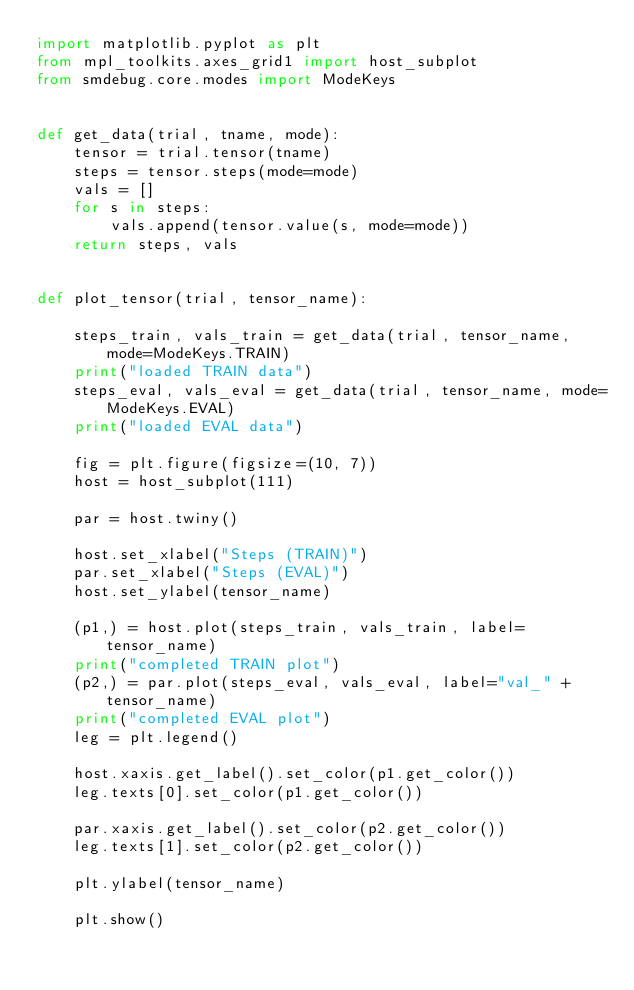Convert code to text. <code><loc_0><loc_0><loc_500><loc_500><_Python_>import matplotlib.pyplot as plt
from mpl_toolkits.axes_grid1 import host_subplot
from smdebug.core.modes import ModeKeys


def get_data(trial, tname, mode):
    tensor = trial.tensor(tname)
    steps = tensor.steps(mode=mode)
    vals = []
    for s in steps:
        vals.append(tensor.value(s, mode=mode))
    return steps, vals


def plot_tensor(trial, tensor_name):

    steps_train, vals_train = get_data(trial, tensor_name, mode=ModeKeys.TRAIN)
    print("loaded TRAIN data")
    steps_eval, vals_eval = get_data(trial, tensor_name, mode=ModeKeys.EVAL)
    print("loaded EVAL data")

    fig = plt.figure(figsize=(10, 7))
    host = host_subplot(111)

    par = host.twiny()

    host.set_xlabel("Steps (TRAIN)")
    par.set_xlabel("Steps (EVAL)")
    host.set_ylabel(tensor_name)

    (p1,) = host.plot(steps_train, vals_train, label=tensor_name)
    print("completed TRAIN plot")
    (p2,) = par.plot(steps_eval, vals_eval, label="val_" + tensor_name)
    print("completed EVAL plot")
    leg = plt.legend()

    host.xaxis.get_label().set_color(p1.get_color())
    leg.texts[0].set_color(p1.get_color())
    
    par.xaxis.get_label().set_color(p2.get_color())
    leg.texts[1].set_color(p2.get_color())

    plt.ylabel(tensor_name)

    plt.show()
</code> 